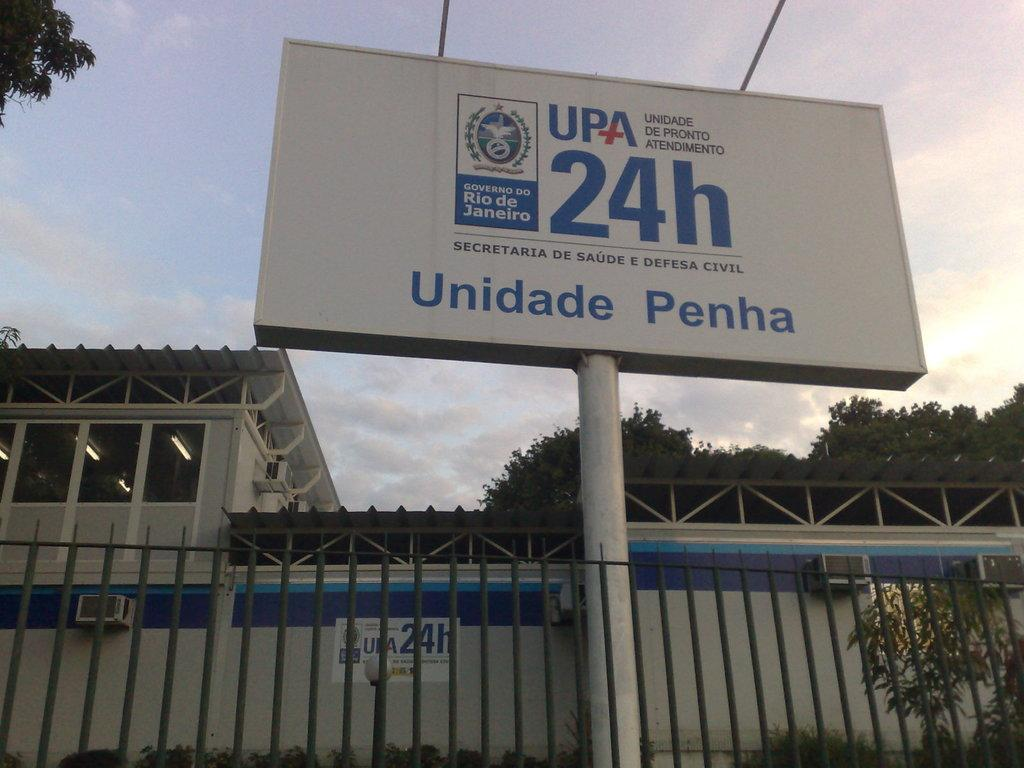<image>
Write a terse but informative summary of the picture. A white sign has the letters of UPA 24H displayed. 